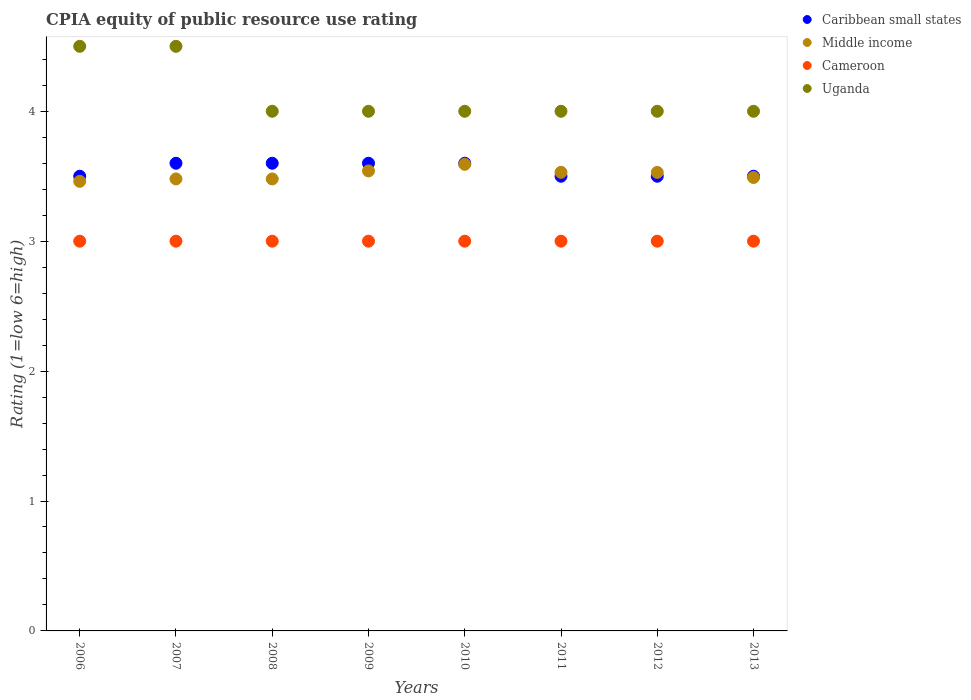How many different coloured dotlines are there?
Ensure brevity in your answer.  4. Is the number of dotlines equal to the number of legend labels?
Make the answer very short. Yes. What is the CPIA rating in Uganda in 2006?
Your answer should be very brief. 4.5. Across all years, what is the maximum CPIA rating in Cameroon?
Give a very brief answer. 3. Across all years, what is the minimum CPIA rating in Middle income?
Offer a very short reply. 3.46. In which year was the CPIA rating in Uganda minimum?
Your answer should be very brief. 2008. What is the total CPIA rating in Middle income in the graph?
Your answer should be very brief. 28.1. What is the difference between the CPIA rating in Uganda in 2009 and that in 2013?
Offer a terse response. 0. What is the difference between the CPIA rating in Uganda in 2008 and the CPIA rating in Middle income in 2012?
Your answer should be compact. 0.47. What is the average CPIA rating in Caribbean small states per year?
Make the answer very short. 3.55. In the year 2011, what is the difference between the CPIA rating in Uganda and CPIA rating in Middle income?
Make the answer very short. 0.47. Is the CPIA rating in Cameroon in 2006 less than that in 2012?
Your response must be concise. No. In how many years, is the CPIA rating in Cameroon greater than the average CPIA rating in Cameroon taken over all years?
Give a very brief answer. 0. Is the sum of the CPIA rating in Middle income in 2009 and 2011 greater than the maximum CPIA rating in Uganda across all years?
Your answer should be very brief. Yes. Is it the case that in every year, the sum of the CPIA rating in Uganda and CPIA rating in Middle income  is greater than the sum of CPIA rating in Cameroon and CPIA rating in Caribbean small states?
Offer a very short reply. Yes. Is the CPIA rating in Caribbean small states strictly less than the CPIA rating in Middle income over the years?
Your answer should be compact. No. Are the values on the major ticks of Y-axis written in scientific E-notation?
Provide a short and direct response. No. Does the graph contain any zero values?
Make the answer very short. No. How many legend labels are there?
Your answer should be very brief. 4. How are the legend labels stacked?
Give a very brief answer. Vertical. What is the title of the graph?
Your response must be concise. CPIA equity of public resource use rating. Does "Australia" appear as one of the legend labels in the graph?
Make the answer very short. No. What is the label or title of the X-axis?
Your response must be concise. Years. What is the Rating (1=low 6=high) in Middle income in 2006?
Your answer should be compact. 3.46. What is the Rating (1=low 6=high) of Uganda in 2006?
Your answer should be very brief. 4.5. What is the Rating (1=low 6=high) in Middle income in 2007?
Keep it short and to the point. 3.48. What is the Rating (1=low 6=high) in Cameroon in 2007?
Offer a very short reply. 3. What is the Rating (1=low 6=high) of Caribbean small states in 2008?
Provide a succinct answer. 3.6. What is the Rating (1=low 6=high) in Middle income in 2008?
Provide a succinct answer. 3.48. What is the Rating (1=low 6=high) of Cameroon in 2008?
Offer a terse response. 3. What is the Rating (1=low 6=high) in Uganda in 2008?
Offer a very short reply. 4. What is the Rating (1=low 6=high) of Middle income in 2009?
Provide a short and direct response. 3.54. What is the Rating (1=low 6=high) of Cameroon in 2009?
Your response must be concise. 3. What is the Rating (1=low 6=high) in Uganda in 2009?
Offer a very short reply. 4. What is the Rating (1=low 6=high) of Middle income in 2010?
Make the answer very short. 3.59. What is the Rating (1=low 6=high) in Cameroon in 2010?
Offer a very short reply. 3. What is the Rating (1=low 6=high) of Uganda in 2010?
Keep it short and to the point. 4. What is the Rating (1=low 6=high) of Middle income in 2011?
Offer a terse response. 3.53. What is the Rating (1=low 6=high) of Cameroon in 2011?
Your answer should be very brief. 3. What is the Rating (1=low 6=high) in Caribbean small states in 2012?
Ensure brevity in your answer.  3.5. What is the Rating (1=low 6=high) in Middle income in 2012?
Make the answer very short. 3.53. What is the Rating (1=low 6=high) in Cameroon in 2012?
Keep it short and to the point. 3. What is the Rating (1=low 6=high) in Middle income in 2013?
Keep it short and to the point. 3.49. What is the Rating (1=low 6=high) of Cameroon in 2013?
Provide a succinct answer. 3. Across all years, what is the maximum Rating (1=low 6=high) of Caribbean small states?
Make the answer very short. 3.6. Across all years, what is the maximum Rating (1=low 6=high) of Middle income?
Offer a terse response. 3.59. Across all years, what is the minimum Rating (1=low 6=high) of Middle income?
Your answer should be compact. 3.46. Across all years, what is the minimum Rating (1=low 6=high) in Cameroon?
Provide a succinct answer. 3. What is the total Rating (1=low 6=high) of Caribbean small states in the graph?
Keep it short and to the point. 28.4. What is the total Rating (1=low 6=high) of Middle income in the graph?
Provide a succinct answer. 28.1. What is the total Rating (1=low 6=high) in Cameroon in the graph?
Offer a terse response. 24. What is the difference between the Rating (1=low 6=high) in Middle income in 2006 and that in 2007?
Your answer should be very brief. -0.02. What is the difference between the Rating (1=low 6=high) of Cameroon in 2006 and that in 2007?
Keep it short and to the point. 0. What is the difference between the Rating (1=low 6=high) in Caribbean small states in 2006 and that in 2008?
Provide a succinct answer. -0.1. What is the difference between the Rating (1=low 6=high) of Middle income in 2006 and that in 2008?
Give a very brief answer. -0.02. What is the difference between the Rating (1=low 6=high) of Cameroon in 2006 and that in 2008?
Make the answer very short. 0. What is the difference between the Rating (1=low 6=high) of Caribbean small states in 2006 and that in 2009?
Make the answer very short. -0.1. What is the difference between the Rating (1=low 6=high) of Middle income in 2006 and that in 2009?
Give a very brief answer. -0.08. What is the difference between the Rating (1=low 6=high) of Cameroon in 2006 and that in 2009?
Your response must be concise. 0. What is the difference between the Rating (1=low 6=high) in Uganda in 2006 and that in 2009?
Your answer should be compact. 0.5. What is the difference between the Rating (1=low 6=high) in Middle income in 2006 and that in 2010?
Your response must be concise. -0.13. What is the difference between the Rating (1=low 6=high) in Cameroon in 2006 and that in 2010?
Give a very brief answer. 0. What is the difference between the Rating (1=low 6=high) of Uganda in 2006 and that in 2010?
Make the answer very short. 0.5. What is the difference between the Rating (1=low 6=high) in Caribbean small states in 2006 and that in 2011?
Offer a terse response. 0. What is the difference between the Rating (1=low 6=high) in Middle income in 2006 and that in 2011?
Give a very brief answer. -0.07. What is the difference between the Rating (1=low 6=high) of Cameroon in 2006 and that in 2011?
Your answer should be compact. 0. What is the difference between the Rating (1=low 6=high) in Uganda in 2006 and that in 2011?
Provide a short and direct response. 0.5. What is the difference between the Rating (1=low 6=high) in Middle income in 2006 and that in 2012?
Provide a short and direct response. -0.07. What is the difference between the Rating (1=low 6=high) of Middle income in 2006 and that in 2013?
Provide a succinct answer. -0.03. What is the difference between the Rating (1=low 6=high) in Uganda in 2006 and that in 2013?
Provide a succinct answer. 0.5. What is the difference between the Rating (1=low 6=high) in Caribbean small states in 2007 and that in 2008?
Your response must be concise. 0. What is the difference between the Rating (1=low 6=high) in Middle income in 2007 and that in 2008?
Give a very brief answer. 0. What is the difference between the Rating (1=low 6=high) in Uganda in 2007 and that in 2008?
Your response must be concise. 0.5. What is the difference between the Rating (1=low 6=high) in Caribbean small states in 2007 and that in 2009?
Provide a short and direct response. 0. What is the difference between the Rating (1=low 6=high) in Middle income in 2007 and that in 2009?
Your answer should be very brief. -0.06. What is the difference between the Rating (1=low 6=high) of Middle income in 2007 and that in 2010?
Provide a short and direct response. -0.11. What is the difference between the Rating (1=low 6=high) in Uganda in 2007 and that in 2010?
Ensure brevity in your answer.  0.5. What is the difference between the Rating (1=low 6=high) in Middle income in 2007 and that in 2011?
Give a very brief answer. -0.05. What is the difference between the Rating (1=low 6=high) of Caribbean small states in 2007 and that in 2012?
Offer a very short reply. 0.1. What is the difference between the Rating (1=low 6=high) in Middle income in 2007 and that in 2012?
Provide a succinct answer. -0.05. What is the difference between the Rating (1=low 6=high) of Cameroon in 2007 and that in 2012?
Your answer should be compact. 0. What is the difference between the Rating (1=low 6=high) in Uganda in 2007 and that in 2012?
Your response must be concise. 0.5. What is the difference between the Rating (1=low 6=high) in Caribbean small states in 2007 and that in 2013?
Provide a succinct answer. 0.1. What is the difference between the Rating (1=low 6=high) in Middle income in 2007 and that in 2013?
Give a very brief answer. -0.01. What is the difference between the Rating (1=low 6=high) of Cameroon in 2007 and that in 2013?
Ensure brevity in your answer.  0. What is the difference between the Rating (1=low 6=high) in Uganda in 2007 and that in 2013?
Make the answer very short. 0.5. What is the difference between the Rating (1=low 6=high) in Caribbean small states in 2008 and that in 2009?
Keep it short and to the point. 0. What is the difference between the Rating (1=low 6=high) in Middle income in 2008 and that in 2009?
Make the answer very short. -0.06. What is the difference between the Rating (1=low 6=high) in Cameroon in 2008 and that in 2009?
Ensure brevity in your answer.  0. What is the difference between the Rating (1=low 6=high) of Uganda in 2008 and that in 2009?
Your answer should be compact. 0. What is the difference between the Rating (1=low 6=high) of Middle income in 2008 and that in 2010?
Your answer should be compact. -0.11. What is the difference between the Rating (1=low 6=high) of Cameroon in 2008 and that in 2010?
Your answer should be very brief. 0. What is the difference between the Rating (1=low 6=high) in Caribbean small states in 2008 and that in 2011?
Offer a terse response. 0.1. What is the difference between the Rating (1=low 6=high) of Middle income in 2008 and that in 2011?
Offer a very short reply. -0.05. What is the difference between the Rating (1=low 6=high) in Uganda in 2008 and that in 2011?
Your response must be concise. 0. What is the difference between the Rating (1=low 6=high) of Middle income in 2008 and that in 2012?
Your response must be concise. -0.05. What is the difference between the Rating (1=low 6=high) in Uganda in 2008 and that in 2012?
Provide a succinct answer. 0. What is the difference between the Rating (1=low 6=high) in Middle income in 2008 and that in 2013?
Keep it short and to the point. -0.01. What is the difference between the Rating (1=low 6=high) of Cameroon in 2008 and that in 2013?
Make the answer very short. 0. What is the difference between the Rating (1=low 6=high) of Caribbean small states in 2009 and that in 2010?
Offer a terse response. 0. What is the difference between the Rating (1=low 6=high) of Middle income in 2009 and that in 2010?
Provide a succinct answer. -0.05. What is the difference between the Rating (1=low 6=high) of Cameroon in 2009 and that in 2010?
Provide a short and direct response. 0. What is the difference between the Rating (1=low 6=high) in Middle income in 2009 and that in 2011?
Give a very brief answer. 0.01. What is the difference between the Rating (1=low 6=high) of Cameroon in 2009 and that in 2011?
Keep it short and to the point. 0. What is the difference between the Rating (1=low 6=high) in Uganda in 2009 and that in 2011?
Provide a succinct answer. 0. What is the difference between the Rating (1=low 6=high) of Caribbean small states in 2009 and that in 2012?
Provide a succinct answer. 0.1. What is the difference between the Rating (1=low 6=high) of Middle income in 2009 and that in 2012?
Provide a succinct answer. 0.01. What is the difference between the Rating (1=low 6=high) of Middle income in 2009 and that in 2013?
Provide a short and direct response. 0.05. What is the difference between the Rating (1=low 6=high) in Cameroon in 2009 and that in 2013?
Provide a succinct answer. 0. What is the difference between the Rating (1=low 6=high) in Caribbean small states in 2010 and that in 2011?
Ensure brevity in your answer.  0.1. What is the difference between the Rating (1=low 6=high) in Middle income in 2010 and that in 2011?
Your answer should be compact. 0.06. What is the difference between the Rating (1=low 6=high) of Uganda in 2010 and that in 2011?
Provide a short and direct response. 0. What is the difference between the Rating (1=low 6=high) of Caribbean small states in 2010 and that in 2012?
Provide a succinct answer. 0.1. What is the difference between the Rating (1=low 6=high) of Middle income in 2010 and that in 2012?
Provide a succinct answer. 0.06. What is the difference between the Rating (1=low 6=high) in Cameroon in 2010 and that in 2012?
Ensure brevity in your answer.  0. What is the difference between the Rating (1=low 6=high) of Uganda in 2010 and that in 2012?
Keep it short and to the point. 0. What is the difference between the Rating (1=low 6=high) of Caribbean small states in 2010 and that in 2013?
Keep it short and to the point. 0.1. What is the difference between the Rating (1=low 6=high) of Middle income in 2010 and that in 2013?
Make the answer very short. 0.1. What is the difference between the Rating (1=low 6=high) in Uganda in 2010 and that in 2013?
Your response must be concise. 0. What is the difference between the Rating (1=low 6=high) in Middle income in 2011 and that in 2012?
Offer a terse response. 0. What is the difference between the Rating (1=low 6=high) of Cameroon in 2011 and that in 2012?
Make the answer very short. 0. What is the difference between the Rating (1=low 6=high) in Middle income in 2011 and that in 2013?
Your answer should be compact. 0.04. What is the difference between the Rating (1=low 6=high) in Cameroon in 2011 and that in 2013?
Make the answer very short. 0. What is the difference between the Rating (1=low 6=high) in Uganda in 2011 and that in 2013?
Offer a terse response. 0. What is the difference between the Rating (1=low 6=high) of Caribbean small states in 2012 and that in 2013?
Offer a very short reply. 0. What is the difference between the Rating (1=low 6=high) of Middle income in 2012 and that in 2013?
Your answer should be compact. 0.04. What is the difference between the Rating (1=low 6=high) in Caribbean small states in 2006 and the Rating (1=low 6=high) in Middle income in 2007?
Your answer should be very brief. 0.02. What is the difference between the Rating (1=low 6=high) in Caribbean small states in 2006 and the Rating (1=low 6=high) in Cameroon in 2007?
Your response must be concise. 0.5. What is the difference between the Rating (1=low 6=high) of Middle income in 2006 and the Rating (1=low 6=high) of Cameroon in 2007?
Give a very brief answer. 0.46. What is the difference between the Rating (1=low 6=high) in Middle income in 2006 and the Rating (1=low 6=high) in Uganda in 2007?
Make the answer very short. -1.04. What is the difference between the Rating (1=low 6=high) in Cameroon in 2006 and the Rating (1=low 6=high) in Uganda in 2007?
Your answer should be compact. -1.5. What is the difference between the Rating (1=low 6=high) of Caribbean small states in 2006 and the Rating (1=low 6=high) of Middle income in 2008?
Your answer should be very brief. 0.02. What is the difference between the Rating (1=low 6=high) of Caribbean small states in 2006 and the Rating (1=low 6=high) of Uganda in 2008?
Your response must be concise. -0.5. What is the difference between the Rating (1=low 6=high) in Middle income in 2006 and the Rating (1=low 6=high) in Cameroon in 2008?
Give a very brief answer. 0.46. What is the difference between the Rating (1=low 6=high) in Middle income in 2006 and the Rating (1=low 6=high) in Uganda in 2008?
Offer a very short reply. -0.54. What is the difference between the Rating (1=low 6=high) in Cameroon in 2006 and the Rating (1=low 6=high) in Uganda in 2008?
Ensure brevity in your answer.  -1. What is the difference between the Rating (1=low 6=high) in Caribbean small states in 2006 and the Rating (1=low 6=high) in Middle income in 2009?
Offer a very short reply. -0.04. What is the difference between the Rating (1=low 6=high) of Caribbean small states in 2006 and the Rating (1=low 6=high) of Uganda in 2009?
Your answer should be very brief. -0.5. What is the difference between the Rating (1=low 6=high) of Middle income in 2006 and the Rating (1=low 6=high) of Cameroon in 2009?
Make the answer very short. 0.46. What is the difference between the Rating (1=low 6=high) of Middle income in 2006 and the Rating (1=low 6=high) of Uganda in 2009?
Offer a very short reply. -0.54. What is the difference between the Rating (1=low 6=high) in Cameroon in 2006 and the Rating (1=low 6=high) in Uganda in 2009?
Ensure brevity in your answer.  -1. What is the difference between the Rating (1=low 6=high) in Caribbean small states in 2006 and the Rating (1=low 6=high) in Middle income in 2010?
Your answer should be compact. -0.09. What is the difference between the Rating (1=low 6=high) of Middle income in 2006 and the Rating (1=low 6=high) of Cameroon in 2010?
Ensure brevity in your answer.  0.46. What is the difference between the Rating (1=low 6=high) in Middle income in 2006 and the Rating (1=low 6=high) in Uganda in 2010?
Ensure brevity in your answer.  -0.54. What is the difference between the Rating (1=low 6=high) of Caribbean small states in 2006 and the Rating (1=low 6=high) of Middle income in 2011?
Provide a succinct answer. -0.03. What is the difference between the Rating (1=low 6=high) of Caribbean small states in 2006 and the Rating (1=low 6=high) of Uganda in 2011?
Give a very brief answer. -0.5. What is the difference between the Rating (1=low 6=high) of Middle income in 2006 and the Rating (1=low 6=high) of Cameroon in 2011?
Give a very brief answer. 0.46. What is the difference between the Rating (1=low 6=high) of Middle income in 2006 and the Rating (1=low 6=high) of Uganda in 2011?
Provide a succinct answer. -0.54. What is the difference between the Rating (1=low 6=high) of Cameroon in 2006 and the Rating (1=low 6=high) of Uganda in 2011?
Offer a very short reply. -1. What is the difference between the Rating (1=low 6=high) in Caribbean small states in 2006 and the Rating (1=low 6=high) in Middle income in 2012?
Provide a short and direct response. -0.03. What is the difference between the Rating (1=low 6=high) of Caribbean small states in 2006 and the Rating (1=low 6=high) of Cameroon in 2012?
Ensure brevity in your answer.  0.5. What is the difference between the Rating (1=low 6=high) in Caribbean small states in 2006 and the Rating (1=low 6=high) in Uganda in 2012?
Provide a short and direct response. -0.5. What is the difference between the Rating (1=low 6=high) of Middle income in 2006 and the Rating (1=low 6=high) of Cameroon in 2012?
Your response must be concise. 0.46. What is the difference between the Rating (1=low 6=high) of Middle income in 2006 and the Rating (1=low 6=high) of Uganda in 2012?
Your answer should be very brief. -0.54. What is the difference between the Rating (1=low 6=high) of Cameroon in 2006 and the Rating (1=low 6=high) of Uganda in 2012?
Offer a very short reply. -1. What is the difference between the Rating (1=low 6=high) of Caribbean small states in 2006 and the Rating (1=low 6=high) of Middle income in 2013?
Provide a succinct answer. 0.01. What is the difference between the Rating (1=low 6=high) in Caribbean small states in 2006 and the Rating (1=low 6=high) in Cameroon in 2013?
Provide a short and direct response. 0.5. What is the difference between the Rating (1=low 6=high) of Middle income in 2006 and the Rating (1=low 6=high) of Cameroon in 2013?
Provide a short and direct response. 0.46. What is the difference between the Rating (1=low 6=high) of Middle income in 2006 and the Rating (1=low 6=high) of Uganda in 2013?
Your response must be concise. -0.54. What is the difference between the Rating (1=low 6=high) of Cameroon in 2006 and the Rating (1=low 6=high) of Uganda in 2013?
Make the answer very short. -1. What is the difference between the Rating (1=low 6=high) of Caribbean small states in 2007 and the Rating (1=low 6=high) of Middle income in 2008?
Provide a short and direct response. 0.12. What is the difference between the Rating (1=low 6=high) in Caribbean small states in 2007 and the Rating (1=low 6=high) in Cameroon in 2008?
Your answer should be very brief. 0.6. What is the difference between the Rating (1=low 6=high) of Caribbean small states in 2007 and the Rating (1=low 6=high) of Uganda in 2008?
Make the answer very short. -0.4. What is the difference between the Rating (1=low 6=high) in Middle income in 2007 and the Rating (1=low 6=high) in Cameroon in 2008?
Provide a short and direct response. 0.48. What is the difference between the Rating (1=low 6=high) of Middle income in 2007 and the Rating (1=low 6=high) of Uganda in 2008?
Provide a short and direct response. -0.52. What is the difference between the Rating (1=low 6=high) in Cameroon in 2007 and the Rating (1=low 6=high) in Uganda in 2008?
Provide a succinct answer. -1. What is the difference between the Rating (1=low 6=high) in Caribbean small states in 2007 and the Rating (1=low 6=high) in Middle income in 2009?
Provide a succinct answer. 0.06. What is the difference between the Rating (1=low 6=high) of Middle income in 2007 and the Rating (1=low 6=high) of Cameroon in 2009?
Make the answer very short. 0.48. What is the difference between the Rating (1=low 6=high) of Middle income in 2007 and the Rating (1=low 6=high) of Uganda in 2009?
Provide a succinct answer. -0.52. What is the difference between the Rating (1=low 6=high) of Cameroon in 2007 and the Rating (1=low 6=high) of Uganda in 2009?
Your response must be concise. -1. What is the difference between the Rating (1=low 6=high) in Caribbean small states in 2007 and the Rating (1=low 6=high) in Middle income in 2010?
Keep it short and to the point. 0.01. What is the difference between the Rating (1=low 6=high) of Caribbean small states in 2007 and the Rating (1=low 6=high) of Cameroon in 2010?
Provide a succinct answer. 0.6. What is the difference between the Rating (1=low 6=high) in Middle income in 2007 and the Rating (1=low 6=high) in Cameroon in 2010?
Provide a short and direct response. 0.48. What is the difference between the Rating (1=low 6=high) of Middle income in 2007 and the Rating (1=low 6=high) of Uganda in 2010?
Give a very brief answer. -0.52. What is the difference between the Rating (1=low 6=high) of Cameroon in 2007 and the Rating (1=low 6=high) of Uganda in 2010?
Ensure brevity in your answer.  -1. What is the difference between the Rating (1=low 6=high) of Caribbean small states in 2007 and the Rating (1=low 6=high) of Middle income in 2011?
Give a very brief answer. 0.07. What is the difference between the Rating (1=low 6=high) in Caribbean small states in 2007 and the Rating (1=low 6=high) in Uganda in 2011?
Provide a succinct answer. -0.4. What is the difference between the Rating (1=low 6=high) of Middle income in 2007 and the Rating (1=low 6=high) of Cameroon in 2011?
Provide a short and direct response. 0.48. What is the difference between the Rating (1=low 6=high) of Middle income in 2007 and the Rating (1=low 6=high) of Uganda in 2011?
Give a very brief answer. -0.52. What is the difference between the Rating (1=low 6=high) of Cameroon in 2007 and the Rating (1=low 6=high) of Uganda in 2011?
Your answer should be very brief. -1. What is the difference between the Rating (1=low 6=high) of Caribbean small states in 2007 and the Rating (1=low 6=high) of Middle income in 2012?
Provide a succinct answer. 0.07. What is the difference between the Rating (1=low 6=high) of Caribbean small states in 2007 and the Rating (1=low 6=high) of Cameroon in 2012?
Offer a terse response. 0.6. What is the difference between the Rating (1=low 6=high) of Caribbean small states in 2007 and the Rating (1=low 6=high) of Uganda in 2012?
Keep it short and to the point. -0.4. What is the difference between the Rating (1=low 6=high) in Middle income in 2007 and the Rating (1=low 6=high) in Cameroon in 2012?
Offer a very short reply. 0.48. What is the difference between the Rating (1=low 6=high) in Middle income in 2007 and the Rating (1=low 6=high) in Uganda in 2012?
Keep it short and to the point. -0.52. What is the difference between the Rating (1=low 6=high) of Caribbean small states in 2007 and the Rating (1=low 6=high) of Middle income in 2013?
Provide a succinct answer. 0.11. What is the difference between the Rating (1=low 6=high) of Middle income in 2007 and the Rating (1=low 6=high) of Cameroon in 2013?
Ensure brevity in your answer.  0.48. What is the difference between the Rating (1=low 6=high) of Middle income in 2007 and the Rating (1=low 6=high) of Uganda in 2013?
Offer a terse response. -0.52. What is the difference between the Rating (1=low 6=high) in Cameroon in 2007 and the Rating (1=low 6=high) in Uganda in 2013?
Your response must be concise. -1. What is the difference between the Rating (1=low 6=high) of Caribbean small states in 2008 and the Rating (1=low 6=high) of Middle income in 2009?
Keep it short and to the point. 0.06. What is the difference between the Rating (1=low 6=high) in Caribbean small states in 2008 and the Rating (1=low 6=high) in Cameroon in 2009?
Offer a terse response. 0.6. What is the difference between the Rating (1=low 6=high) of Middle income in 2008 and the Rating (1=low 6=high) of Cameroon in 2009?
Give a very brief answer. 0.48. What is the difference between the Rating (1=low 6=high) in Middle income in 2008 and the Rating (1=low 6=high) in Uganda in 2009?
Provide a succinct answer. -0.52. What is the difference between the Rating (1=low 6=high) of Cameroon in 2008 and the Rating (1=low 6=high) of Uganda in 2009?
Your response must be concise. -1. What is the difference between the Rating (1=low 6=high) in Caribbean small states in 2008 and the Rating (1=low 6=high) in Middle income in 2010?
Your answer should be very brief. 0.01. What is the difference between the Rating (1=low 6=high) of Middle income in 2008 and the Rating (1=low 6=high) of Cameroon in 2010?
Offer a very short reply. 0.48. What is the difference between the Rating (1=low 6=high) of Middle income in 2008 and the Rating (1=low 6=high) of Uganda in 2010?
Your answer should be compact. -0.52. What is the difference between the Rating (1=low 6=high) in Cameroon in 2008 and the Rating (1=low 6=high) in Uganda in 2010?
Provide a short and direct response. -1. What is the difference between the Rating (1=low 6=high) of Caribbean small states in 2008 and the Rating (1=low 6=high) of Middle income in 2011?
Make the answer very short. 0.07. What is the difference between the Rating (1=low 6=high) of Middle income in 2008 and the Rating (1=low 6=high) of Cameroon in 2011?
Make the answer very short. 0.48. What is the difference between the Rating (1=low 6=high) of Middle income in 2008 and the Rating (1=low 6=high) of Uganda in 2011?
Your response must be concise. -0.52. What is the difference between the Rating (1=low 6=high) of Cameroon in 2008 and the Rating (1=low 6=high) of Uganda in 2011?
Offer a terse response. -1. What is the difference between the Rating (1=low 6=high) in Caribbean small states in 2008 and the Rating (1=low 6=high) in Middle income in 2012?
Keep it short and to the point. 0.07. What is the difference between the Rating (1=low 6=high) of Middle income in 2008 and the Rating (1=low 6=high) of Cameroon in 2012?
Ensure brevity in your answer.  0.48. What is the difference between the Rating (1=low 6=high) in Middle income in 2008 and the Rating (1=low 6=high) in Uganda in 2012?
Your answer should be compact. -0.52. What is the difference between the Rating (1=low 6=high) of Caribbean small states in 2008 and the Rating (1=low 6=high) of Middle income in 2013?
Make the answer very short. 0.11. What is the difference between the Rating (1=low 6=high) in Caribbean small states in 2008 and the Rating (1=low 6=high) in Cameroon in 2013?
Provide a short and direct response. 0.6. What is the difference between the Rating (1=low 6=high) of Middle income in 2008 and the Rating (1=low 6=high) of Cameroon in 2013?
Keep it short and to the point. 0.48. What is the difference between the Rating (1=low 6=high) of Middle income in 2008 and the Rating (1=low 6=high) of Uganda in 2013?
Your answer should be compact. -0.52. What is the difference between the Rating (1=low 6=high) of Caribbean small states in 2009 and the Rating (1=low 6=high) of Middle income in 2010?
Ensure brevity in your answer.  0.01. What is the difference between the Rating (1=low 6=high) of Caribbean small states in 2009 and the Rating (1=low 6=high) of Cameroon in 2010?
Provide a short and direct response. 0.6. What is the difference between the Rating (1=low 6=high) in Caribbean small states in 2009 and the Rating (1=low 6=high) in Uganda in 2010?
Offer a very short reply. -0.4. What is the difference between the Rating (1=low 6=high) of Middle income in 2009 and the Rating (1=low 6=high) of Cameroon in 2010?
Offer a terse response. 0.54. What is the difference between the Rating (1=low 6=high) of Middle income in 2009 and the Rating (1=low 6=high) of Uganda in 2010?
Give a very brief answer. -0.46. What is the difference between the Rating (1=low 6=high) of Cameroon in 2009 and the Rating (1=low 6=high) of Uganda in 2010?
Give a very brief answer. -1. What is the difference between the Rating (1=low 6=high) in Caribbean small states in 2009 and the Rating (1=low 6=high) in Middle income in 2011?
Keep it short and to the point. 0.07. What is the difference between the Rating (1=low 6=high) of Caribbean small states in 2009 and the Rating (1=low 6=high) of Uganda in 2011?
Your answer should be compact. -0.4. What is the difference between the Rating (1=low 6=high) of Middle income in 2009 and the Rating (1=low 6=high) of Cameroon in 2011?
Your answer should be compact. 0.54. What is the difference between the Rating (1=low 6=high) in Middle income in 2009 and the Rating (1=low 6=high) in Uganda in 2011?
Make the answer very short. -0.46. What is the difference between the Rating (1=low 6=high) of Cameroon in 2009 and the Rating (1=low 6=high) of Uganda in 2011?
Ensure brevity in your answer.  -1. What is the difference between the Rating (1=low 6=high) in Caribbean small states in 2009 and the Rating (1=low 6=high) in Middle income in 2012?
Keep it short and to the point. 0.07. What is the difference between the Rating (1=low 6=high) in Caribbean small states in 2009 and the Rating (1=low 6=high) in Cameroon in 2012?
Keep it short and to the point. 0.6. What is the difference between the Rating (1=low 6=high) of Middle income in 2009 and the Rating (1=low 6=high) of Cameroon in 2012?
Provide a short and direct response. 0.54. What is the difference between the Rating (1=low 6=high) of Middle income in 2009 and the Rating (1=low 6=high) of Uganda in 2012?
Offer a very short reply. -0.46. What is the difference between the Rating (1=low 6=high) in Caribbean small states in 2009 and the Rating (1=low 6=high) in Middle income in 2013?
Make the answer very short. 0.11. What is the difference between the Rating (1=low 6=high) of Middle income in 2009 and the Rating (1=low 6=high) of Cameroon in 2013?
Your response must be concise. 0.54. What is the difference between the Rating (1=low 6=high) of Middle income in 2009 and the Rating (1=low 6=high) of Uganda in 2013?
Provide a short and direct response. -0.46. What is the difference between the Rating (1=low 6=high) of Caribbean small states in 2010 and the Rating (1=low 6=high) of Middle income in 2011?
Keep it short and to the point. 0.07. What is the difference between the Rating (1=low 6=high) of Caribbean small states in 2010 and the Rating (1=low 6=high) of Uganda in 2011?
Offer a terse response. -0.4. What is the difference between the Rating (1=low 6=high) in Middle income in 2010 and the Rating (1=low 6=high) in Cameroon in 2011?
Offer a very short reply. 0.59. What is the difference between the Rating (1=low 6=high) in Middle income in 2010 and the Rating (1=low 6=high) in Uganda in 2011?
Your answer should be very brief. -0.41. What is the difference between the Rating (1=low 6=high) in Caribbean small states in 2010 and the Rating (1=low 6=high) in Middle income in 2012?
Your response must be concise. 0.07. What is the difference between the Rating (1=low 6=high) in Caribbean small states in 2010 and the Rating (1=low 6=high) in Cameroon in 2012?
Ensure brevity in your answer.  0.6. What is the difference between the Rating (1=low 6=high) in Caribbean small states in 2010 and the Rating (1=low 6=high) in Uganda in 2012?
Provide a succinct answer. -0.4. What is the difference between the Rating (1=low 6=high) of Middle income in 2010 and the Rating (1=low 6=high) of Cameroon in 2012?
Provide a short and direct response. 0.59. What is the difference between the Rating (1=low 6=high) in Middle income in 2010 and the Rating (1=low 6=high) in Uganda in 2012?
Your response must be concise. -0.41. What is the difference between the Rating (1=low 6=high) of Caribbean small states in 2010 and the Rating (1=low 6=high) of Middle income in 2013?
Your response must be concise. 0.11. What is the difference between the Rating (1=low 6=high) of Caribbean small states in 2010 and the Rating (1=low 6=high) of Uganda in 2013?
Give a very brief answer. -0.4. What is the difference between the Rating (1=low 6=high) of Middle income in 2010 and the Rating (1=low 6=high) of Cameroon in 2013?
Your response must be concise. 0.59. What is the difference between the Rating (1=low 6=high) of Middle income in 2010 and the Rating (1=low 6=high) of Uganda in 2013?
Offer a very short reply. -0.41. What is the difference between the Rating (1=low 6=high) of Caribbean small states in 2011 and the Rating (1=low 6=high) of Middle income in 2012?
Give a very brief answer. -0.03. What is the difference between the Rating (1=low 6=high) of Caribbean small states in 2011 and the Rating (1=low 6=high) of Uganda in 2012?
Keep it short and to the point. -0.5. What is the difference between the Rating (1=low 6=high) in Middle income in 2011 and the Rating (1=low 6=high) in Cameroon in 2012?
Ensure brevity in your answer.  0.53. What is the difference between the Rating (1=low 6=high) of Middle income in 2011 and the Rating (1=low 6=high) of Uganda in 2012?
Your answer should be compact. -0.47. What is the difference between the Rating (1=low 6=high) of Caribbean small states in 2011 and the Rating (1=low 6=high) of Middle income in 2013?
Make the answer very short. 0.01. What is the difference between the Rating (1=low 6=high) of Caribbean small states in 2011 and the Rating (1=low 6=high) of Cameroon in 2013?
Offer a terse response. 0.5. What is the difference between the Rating (1=low 6=high) in Middle income in 2011 and the Rating (1=low 6=high) in Cameroon in 2013?
Give a very brief answer. 0.53. What is the difference between the Rating (1=low 6=high) of Middle income in 2011 and the Rating (1=low 6=high) of Uganda in 2013?
Ensure brevity in your answer.  -0.47. What is the difference between the Rating (1=low 6=high) of Cameroon in 2011 and the Rating (1=low 6=high) of Uganda in 2013?
Your response must be concise. -1. What is the difference between the Rating (1=low 6=high) in Caribbean small states in 2012 and the Rating (1=low 6=high) in Middle income in 2013?
Ensure brevity in your answer.  0.01. What is the difference between the Rating (1=low 6=high) of Caribbean small states in 2012 and the Rating (1=low 6=high) of Cameroon in 2013?
Keep it short and to the point. 0.5. What is the difference between the Rating (1=low 6=high) in Caribbean small states in 2012 and the Rating (1=low 6=high) in Uganda in 2013?
Your answer should be very brief. -0.5. What is the difference between the Rating (1=low 6=high) of Middle income in 2012 and the Rating (1=low 6=high) of Cameroon in 2013?
Make the answer very short. 0.53. What is the difference between the Rating (1=low 6=high) in Middle income in 2012 and the Rating (1=low 6=high) in Uganda in 2013?
Your answer should be compact. -0.47. What is the average Rating (1=low 6=high) of Caribbean small states per year?
Make the answer very short. 3.55. What is the average Rating (1=low 6=high) in Middle income per year?
Ensure brevity in your answer.  3.51. What is the average Rating (1=low 6=high) in Uganda per year?
Your response must be concise. 4.12. In the year 2006, what is the difference between the Rating (1=low 6=high) of Caribbean small states and Rating (1=low 6=high) of Middle income?
Keep it short and to the point. 0.04. In the year 2006, what is the difference between the Rating (1=low 6=high) of Middle income and Rating (1=low 6=high) of Cameroon?
Keep it short and to the point. 0.46. In the year 2006, what is the difference between the Rating (1=low 6=high) of Middle income and Rating (1=low 6=high) of Uganda?
Provide a short and direct response. -1.04. In the year 2006, what is the difference between the Rating (1=low 6=high) of Cameroon and Rating (1=low 6=high) of Uganda?
Make the answer very short. -1.5. In the year 2007, what is the difference between the Rating (1=low 6=high) of Caribbean small states and Rating (1=low 6=high) of Middle income?
Your answer should be compact. 0.12. In the year 2007, what is the difference between the Rating (1=low 6=high) of Caribbean small states and Rating (1=low 6=high) of Uganda?
Ensure brevity in your answer.  -0.9. In the year 2007, what is the difference between the Rating (1=low 6=high) in Middle income and Rating (1=low 6=high) in Cameroon?
Give a very brief answer. 0.48. In the year 2007, what is the difference between the Rating (1=low 6=high) in Middle income and Rating (1=low 6=high) in Uganda?
Make the answer very short. -1.02. In the year 2007, what is the difference between the Rating (1=low 6=high) in Cameroon and Rating (1=low 6=high) in Uganda?
Ensure brevity in your answer.  -1.5. In the year 2008, what is the difference between the Rating (1=low 6=high) of Caribbean small states and Rating (1=low 6=high) of Middle income?
Provide a succinct answer. 0.12. In the year 2008, what is the difference between the Rating (1=low 6=high) of Middle income and Rating (1=low 6=high) of Cameroon?
Your answer should be compact. 0.48. In the year 2008, what is the difference between the Rating (1=low 6=high) of Middle income and Rating (1=low 6=high) of Uganda?
Offer a very short reply. -0.52. In the year 2008, what is the difference between the Rating (1=low 6=high) of Cameroon and Rating (1=low 6=high) of Uganda?
Keep it short and to the point. -1. In the year 2009, what is the difference between the Rating (1=low 6=high) of Caribbean small states and Rating (1=low 6=high) of Middle income?
Your response must be concise. 0.06. In the year 2009, what is the difference between the Rating (1=low 6=high) in Caribbean small states and Rating (1=low 6=high) in Uganda?
Ensure brevity in your answer.  -0.4. In the year 2009, what is the difference between the Rating (1=low 6=high) in Middle income and Rating (1=low 6=high) in Cameroon?
Your answer should be very brief. 0.54. In the year 2009, what is the difference between the Rating (1=low 6=high) in Middle income and Rating (1=low 6=high) in Uganda?
Ensure brevity in your answer.  -0.46. In the year 2009, what is the difference between the Rating (1=low 6=high) of Cameroon and Rating (1=low 6=high) of Uganda?
Your answer should be compact. -1. In the year 2010, what is the difference between the Rating (1=low 6=high) of Caribbean small states and Rating (1=low 6=high) of Middle income?
Make the answer very short. 0.01. In the year 2010, what is the difference between the Rating (1=low 6=high) in Caribbean small states and Rating (1=low 6=high) in Cameroon?
Provide a short and direct response. 0.6. In the year 2010, what is the difference between the Rating (1=low 6=high) of Middle income and Rating (1=low 6=high) of Cameroon?
Your response must be concise. 0.59. In the year 2010, what is the difference between the Rating (1=low 6=high) of Middle income and Rating (1=low 6=high) of Uganda?
Offer a terse response. -0.41. In the year 2011, what is the difference between the Rating (1=low 6=high) in Caribbean small states and Rating (1=low 6=high) in Middle income?
Give a very brief answer. -0.03. In the year 2011, what is the difference between the Rating (1=low 6=high) in Caribbean small states and Rating (1=low 6=high) in Cameroon?
Offer a terse response. 0.5. In the year 2011, what is the difference between the Rating (1=low 6=high) of Middle income and Rating (1=low 6=high) of Cameroon?
Your answer should be very brief. 0.53. In the year 2011, what is the difference between the Rating (1=low 6=high) of Middle income and Rating (1=low 6=high) of Uganda?
Provide a short and direct response. -0.47. In the year 2011, what is the difference between the Rating (1=low 6=high) in Cameroon and Rating (1=low 6=high) in Uganda?
Offer a very short reply. -1. In the year 2012, what is the difference between the Rating (1=low 6=high) in Caribbean small states and Rating (1=low 6=high) in Middle income?
Keep it short and to the point. -0.03. In the year 2012, what is the difference between the Rating (1=low 6=high) in Caribbean small states and Rating (1=low 6=high) in Cameroon?
Give a very brief answer. 0.5. In the year 2012, what is the difference between the Rating (1=low 6=high) in Middle income and Rating (1=low 6=high) in Cameroon?
Offer a terse response. 0.53. In the year 2012, what is the difference between the Rating (1=low 6=high) of Middle income and Rating (1=low 6=high) of Uganda?
Ensure brevity in your answer.  -0.47. In the year 2013, what is the difference between the Rating (1=low 6=high) in Caribbean small states and Rating (1=low 6=high) in Middle income?
Give a very brief answer. 0.01. In the year 2013, what is the difference between the Rating (1=low 6=high) of Middle income and Rating (1=low 6=high) of Cameroon?
Provide a short and direct response. 0.49. In the year 2013, what is the difference between the Rating (1=low 6=high) in Middle income and Rating (1=low 6=high) in Uganda?
Keep it short and to the point. -0.51. What is the ratio of the Rating (1=low 6=high) of Caribbean small states in 2006 to that in 2007?
Offer a very short reply. 0.97. What is the ratio of the Rating (1=low 6=high) in Middle income in 2006 to that in 2007?
Give a very brief answer. 0.99. What is the ratio of the Rating (1=low 6=high) of Caribbean small states in 2006 to that in 2008?
Keep it short and to the point. 0.97. What is the ratio of the Rating (1=low 6=high) in Middle income in 2006 to that in 2008?
Offer a very short reply. 0.99. What is the ratio of the Rating (1=low 6=high) of Uganda in 2006 to that in 2008?
Offer a terse response. 1.12. What is the ratio of the Rating (1=low 6=high) in Caribbean small states in 2006 to that in 2009?
Your answer should be very brief. 0.97. What is the ratio of the Rating (1=low 6=high) of Middle income in 2006 to that in 2009?
Your response must be concise. 0.98. What is the ratio of the Rating (1=low 6=high) in Cameroon in 2006 to that in 2009?
Your response must be concise. 1. What is the ratio of the Rating (1=low 6=high) in Caribbean small states in 2006 to that in 2010?
Make the answer very short. 0.97. What is the ratio of the Rating (1=low 6=high) of Middle income in 2006 to that in 2010?
Your answer should be very brief. 0.96. What is the ratio of the Rating (1=low 6=high) in Middle income in 2006 to that in 2011?
Make the answer very short. 0.98. What is the ratio of the Rating (1=low 6=high) in Uganda in 2006 to that in 2011?
Ensure brevity in your answer.  1.12. What is the ratio of the Rating (1=low 6=high) in Caribbean small states in 2006 to that in 2012?
Your answer should be compact. 1. What is the ratio of the Rating (1=low 6=high) of Middle income in 2006 to that in 2012?
Keep it short and to the point. 0.98. What is the ratio of the Rating (1=low 6=high) of Uganda in 2006 to that in 2012?
Give a very brief answer. 1.12. What is the ratio of the Rating (1=low 6=high) of Uganda in 2006 to that in 2013?
Give a very brief answer. 1.12. What is the ratio of the Rating (1=low 6=high) in Caribbean small states in 2007 to that in 2008?
Give a very brief answer. 1. What is the ratio of the Rating (1=low 6=high) of Middle income in 2007 to that in 2009?
Provide a short and direct response. 0.98. What is the ratio of the Rating (1=low 6=high) in Cameroon in 2007 to that in 2009?
Make the answer very short. 1. What is the ratio of the Rating (1=low 6=high) of Caribbean small states in 2007 to that in 2010?
Your response must be concise. 1. What is the ratio of the Rating (1=low 6=high) in Middle income in 2007 to that in 2010?
Offer a terse response. 0.97. What is the ratio of the Rating (1=low 6=high) in Cameroon in 2007 to that in 2010?
Ensure brevity in your answer.  1. What is the ratio of the Rating (1=low 6=high) in Caribbean small states in 2007 to that in 2011?
Offer a terse response. 1.03. What is the ratio of the Rating (1=low 6=high) in Middle income in 2007 to that in 2011?
Give a very brief answer. 0.99. What is the ratio of the Rating (1=low 6=high) of Caribbean small states in 2007 to that in 2012?
Offer a terse response. 1.03. What is the ratio of the Rating (1=low 6=high) in Middle income in 2007 to that in 2012?
Make the answer very short. 0.99. What is the ratio of the Rating (1=low 6=high) in Cameroon in 2007 to that in 2012?
Your answer should be compact. 1. What is the ratio of the Rating (1=low 6=high) of Caribbean small states in 2007 to that in 2013?
Ensure brevity in your answer.  1.03. What is the ratio of the Rating (1=low 6=high) of Middle income in 2007 to that in 2013?
Offer a very short reply. 1. What is the ratio of the Rating (1=low 6=high) in Cameroon in 2007 to that in 2013?
Offer a terse response. 1. What is the ratio of the Rating (1=low 6=high) of Uganda in 2007 to that in 2013?
Offer a very short reply. 1.12. What is the ratio of the Rating (1=low 6=high) of Middle income in 2008 to that in 2009?
Keep it short and to the point. 0.98. What is the ratio of the Rating (1=low 6=high) of Cameroon in 2008 to that in 2009?
Give a very brief answer. 1. What is the ratio of the Rating (1=low 6=high) of Caribbean small states in 2008 to that in 2010?
Offer a terse response. 1. What is the ratio of the Rating (1=low 6=high) in Middle income in 2008 to that in 2010?
Your answer should be compact. 0.97. What is the ratio of the Rating (1=low 6=high) in Caribbean small states in 2008 to that in 2011?
Offer a very short reply. 1.03. What is the ratio of the Rating (1=low 6=high) of Middle income in 2008 to that in 2011?
Provide a succinct answer. 0.99. What is the ratio of the Rating (1=low 6=high) of Uganda in 2008 to that in 2011?
Keep it short and to the point. 1. What is the ratio of the Rating (1=low 6=high) in Caribbean small states in 2008 to that in 2012?
Your answer should be very brief. 1.03. What is the ratio of the Rating (1=low 6=high) in Middle income in 2008 to that in 2012?
Your response must be concise. 0.99. What is the ratio of the Rating (1=low 6=high) in Cameroon in 2008 to that in 2012?
Your answer should be compact. 1. What is the ratio of the Rating (1=low 6=high) of Caribbean small states in 2008 to that in 2013?
Ensure brevity in your answer.  1.03. What is the ratio of the Rating (1=low 6=high) of Caribbean small states in 2009 to that in 2010?
Ensure brevity in your answer.  1. What is the ratio of the Rating (1=low 6=high) in Middle income in 2009 to that in 2010?
Provide a succinct answer. 0.99. What is the ratio of the Rating (1=low 6=high) of Caribbean small states in 2009 to that in 2011?
Ensure brevity in your answer.  1.03. What is the ratio of the Rating (1=low 6=high) in Middle income in 2009 to that in 2011?
Give a very brief answer. 1. What is the ratio of the Rating (1=low 6=high) in Cameroon in 2009 to that in 2011?
Offer a very short reply. 1. What is the ratio of the Rating (1=low 6=high) in Uganda in 2009 to that in 2011?
Your answer should be compact. 1. What is the ratio of the Rating (1=low 6=high) of Caribbean small states in 2009 to that in 2012?
Keep it short and to the point. 1.03. What is the ratio of the Rating (1=low 6=high) of Middle income in 2009 to that in 2012?
Offer a terse response. 1. What is the ratio of the Rating (1=low 6=high) of Cameroon in 2009 to that in 2012?
Make the answer very short. 1. What is the ratio of the Rating (1=low 6=high) of Caribbean small states in 2009 to that in 2013?
Your answer should be very brief. 1.03. What is the ratio of the Rating (1=low 6=high) of Middle income in 2009 to that in 2013?
Keep it short and to the point. 1.01. What is the ratio of the Rating (1=low 6=high) in Cameroon in 2009 to that in 2013?
Your answer should be compact. 1. What is the ratio of the Rating (1=low 6=high) in Caribbean small states in 2010 to that in 2011?
Give a very brief answer. 1.03. What is the ratio of the Rating (1=low 6=high) of Middle income in 2010 to that in 2011?
Your answer should be very brief. 1.02. What is the ratio of the Rating (1=low 6=high) in Cameroon in 2010 to that in 2011?
Give a very brief answer. 1. What is the ratio of the Rating (1=low 6=high) in Caribbean small states in 2010 to that in 2012?
Provide a succinct answer. 1.03. What is the ratio of the Rating (1=low 6=high) of Middle income in 2010 to that in 2012?
Provide a short and direct response. 1.02. What is the ratio of the Rating (1=low 6=high) of Cameroon in 2010 to that in 2012?
Make the answer very short. 1. What is the ratio of the Rating (1=low 6=high) in Uganda in 2010 to that in 2012?
Keep it short and to the point. 1. What is the ratio of the Rating (1=low 6=high) of Caribbean small states in 2010 to that in 2013?
Ensure brevity in your answer.  1.03. What is the ratio of the Rating (1=low 6=high) of Middle income in 2010 to that in 2013?
Your answer should be compact. 1.03. What is the ratio of the Rating (1=low 6=high) of Uganda in 2010 to that in 2013?
Provide a short and direct response. 1. What is the ratio of the Rating (1=low 6=high) of Caribbean small states in 2011 to that in 2012?
Give a very brief answer. 1. What is the ratio of the Rating (1=low 6=high) in Caribbean small states in 2011 to that in 2013?
Provide a succinct answer. 1. What is the ratio of the Rating (1=low 6=high) of Middle income in 2011 to that in 2013?
Provide a succinct answer. 1.01. What is the ratio of the Rating (1=low 6=high) in Cameroon in 2011 to that in 2013?
Ensure brevity in your answer.  1. What is the ratio of the Rating (1=low 6=high) in Middle income in 2012 to that in 2013?
Make the answer very short. 1.01. What is the ratio of the Rating (1=low 6=high) of Cameroon in 2012 to that in 2013?
Ensure brevity in your answer.  1. What is the ratio of the Rating (1=low 6=high) in Uganda in 2012 to that in 2013?
Keep it short and to the point. 1. What is the difference between the highest and the second highest Rating (1=low 6=high) of Middle income?
Your answer should be compact. 0.05. What is the difference between the highest and the second highest Rating (1=low 6=high) of Uganda?
Make the answer very short. 0. What is the difference between the highest and the lowest Rating (1=low 6=high) of Caribbean small states?
Ensure brevity in your answer.  0.1. What is the difference between the highest and the lowest Rating (1=low 6=high) of Middle income?
Provide a succinct answer. 0.13. What is the difference between the highest and the lowest Rating (1=low 6=high) in Cameroon?
Offer a very short reply. 0. 